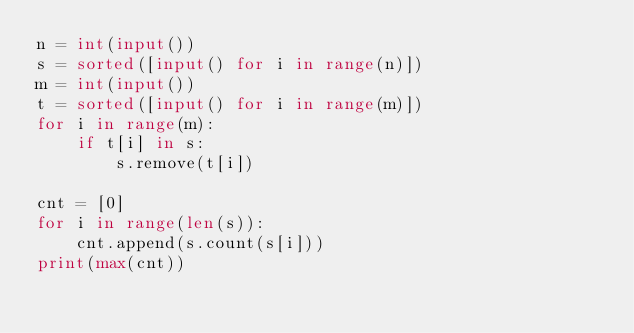Convert code to text. <code><loc_0><loc_0><loc_500><loc_500><_Python_>n = int(input())
s = sorted([input() for i in range(n)])
m = int(input())
t = sorted([input() for i in range(m)])
for i in range(m):
    if t[i] in s:
        s.remove(t[i])

cnt = [0]
for i in range(len(s)):
    cnt.append(s.count(s[i]))
print(max(cnt))</code> 